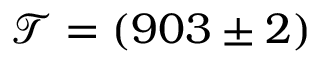<formula> <loc_0><loc_0><loc_500><loc_500>\mathcal { T } = ( 9 0 3 \pm 2 )</formula> 